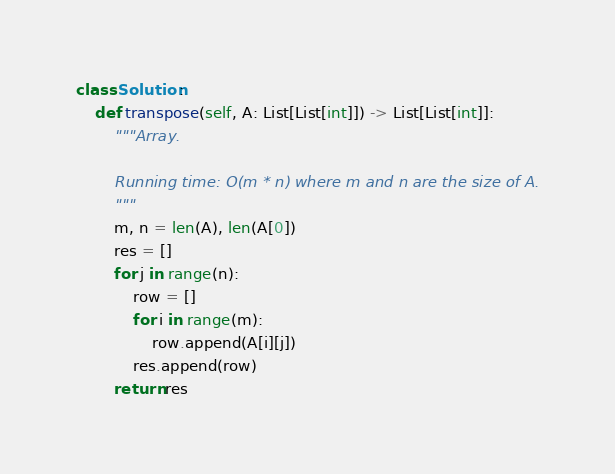<code> <loc_0><loc_0><loc_500><loc_500><_Python_>class Solution:
    def transpose(self, A: List[List[int]]) -> List[List[int]]:
    	"""Array.

    	Running time: O(m * n) where m and n are the size of A.
    	"""
        m, n = len(A), len(A[0])
        res = []
        for j in range(n):
            row = []
            for i in range(m):
                row.append(A[i][j])
            res.append(row)
        return res
</code> 